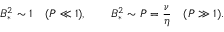<formula> <loc_0><loc_0><loc_500><loc_500>B _ { * } ^ { 2 } \sim 1 \quad ( P \ll 1 ) , \quad B _ { * } ^ { 2 } \sim P = \frac { \nu } { \eta } \quad ( P \gg 1 ) .</formula> 